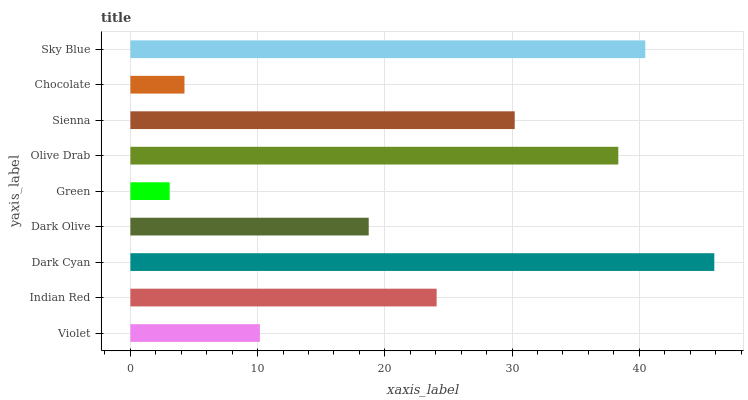Is Green the minimum?
Answer yes or no. Yes. Is Dark Cyan the maximum?
Answer yes or no. Yes. Is Indian Red the minimum?
Answer yes or no. No. Is Indian Red the maximum?
Answer yes or no. No. Is Indian Red greater than Violet?
Answer yes or no. Yes. Is Violet less than Indian Red?
Answer yes or no. Yes. Is Violet greater than Indian Red?
Answer yes or no. No. Is Indian Red less than Violet?
Answer yes or no. No. Is Indian Red the high median?
Answer yes or no. Yes. Is Indian Red the low median?
Answer yes or no. Yes. Is Sky Blue the high median?
Answer yes or no. No. Is Green the low median?
Answer yes or no. No. 